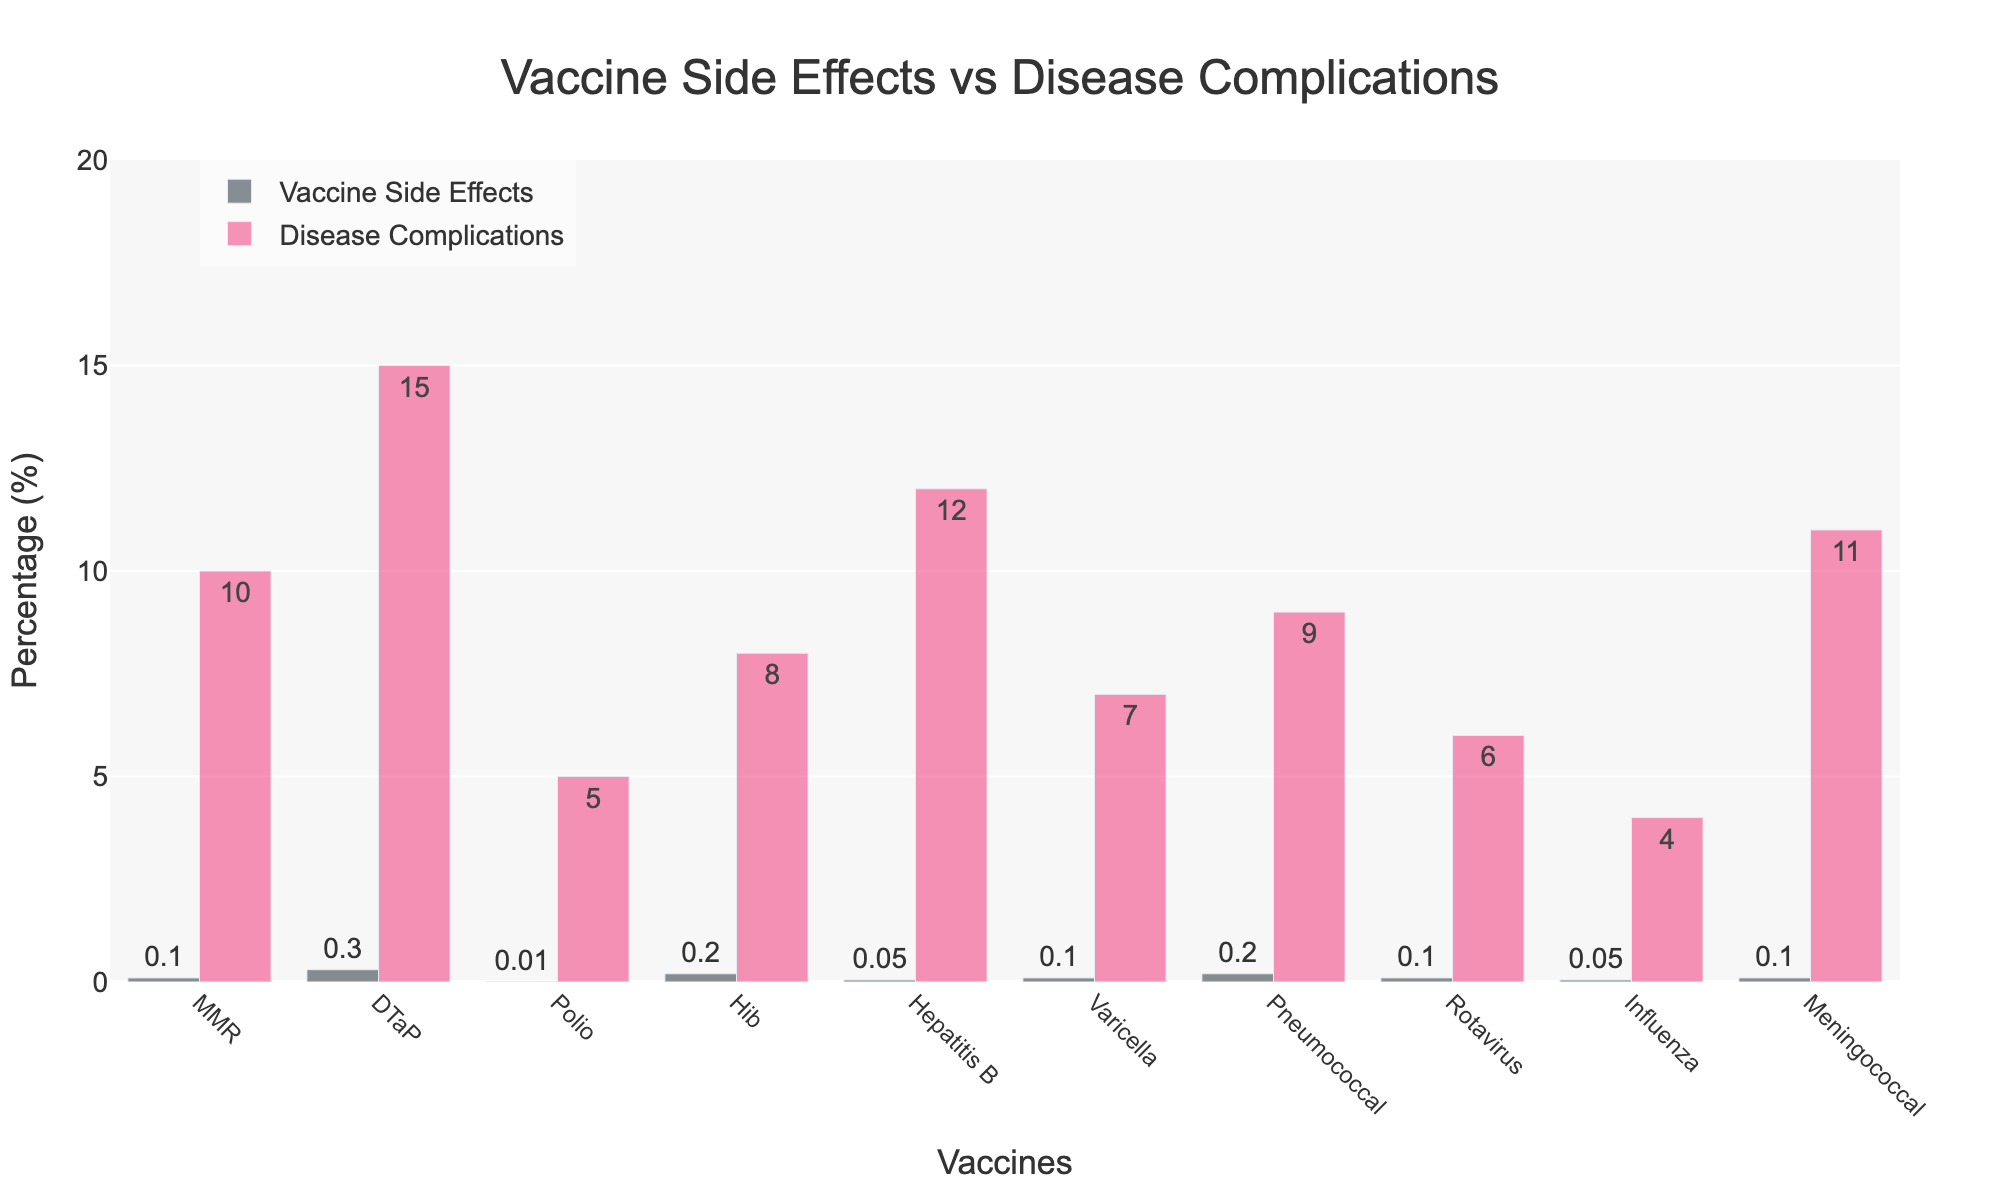Which vaccine has the highest percentage of side effects? To determine which vaccine has the highest percentage of side effects, look at the values in the "Side Effects (%)" column and identify the maximum value.
Answer: DTaP Which disease has the lowest percentage of complications? To find the disease with the lowest percentage of complications, compare the values in the "Disease Complications (%)" column and select the minimum value.
Answer: Influenza What is the difference between the side effects of the DTaP vaccine and the complications of the disease it prevents? Subtract the percentage value of the DTaP vaccine side effects from the percentage value of DTaP disease complications: 15 - 0.3
Answer: 14.7 What is the average percentage of side effects for all vaccines? Sum all the side effect percentages and divide by the number of vaccines: (0.1+0.3+0.01+0.2+0.05+0.1+0.2+0.1+0.05+0.1) / 10 = 1.21 / 10
Answer: 0.121 How many vaccines have a side effect percentage below 0.1%? Count the number of vaccines with side effect percentages below 0.1 by examining each value: Polio and Hepatitis B are below 0.1%
Answer: 2 Which vaccine and corresponding disease pair shows the largest difference in percentages between side effects and complications? Subtract the side effect percentage from the disease complication percentage for each pair. Identify the pair with the largest resulting value. Calculations: MMR (10-0.1=9.9), DTaP (15-0.3=14.7), Polio (5-0.01=4.99), Hib (8-0.2=7.8), HepB (12-0.05=11.95), Varicella (7-0.1=6.9), Pneumococcal (9-0.2=8.8), Rotavirus (6-0.1=5.9), Influenza (4-0.05=3.95), Meningococcal (11-0.1=10.9). The largest difference is for the DTaP vaccine.
Answer: DTaP Which vaccine has a side effect percentage equal to its corresponding disease complication percentage? Compare the side effect percentages and the disease complication percentages to find any pairs that are equal.
Answer: None By how much do the side effects of the Hib vaccine exceed those of the Polio vaccine? Subtract the Polio vaccine side effect percentage from the Hib vaccine side effect percentage: 0.2 - 0.01
Answer: 0.19 Is there any vaccine where the side effects exceed its corresponding disease complications? Compare each vaccine's side effect percentage to its disease complication percentage to see if any side effects are higher.
Answer: No 